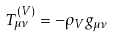<formula> <loc_0><loc_0><loc_500><loc_500>T ^ { ( V ) } _ { \mu \nu } = - \rho _ { V } g _ { \mu \nu }</formula> 